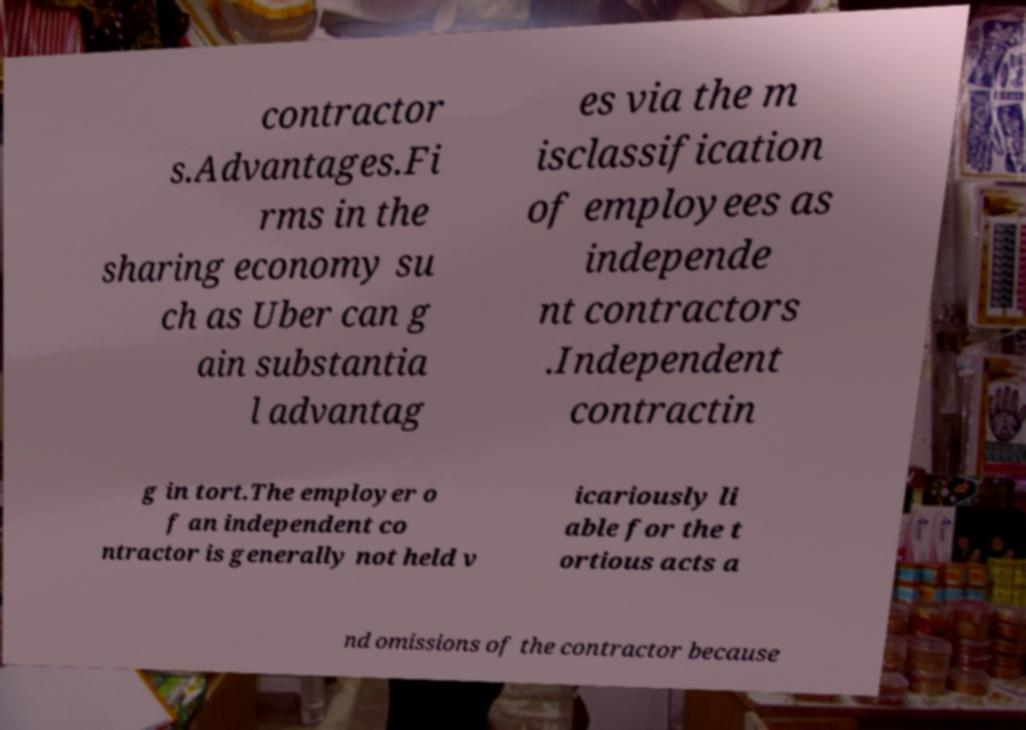Could you assist in decoding the text presented in this image and type it out clearly? contractor s.Advantages.Fi rms in the sharing economy su ch as Uber can g ain substantia l advantag es via the m isclassification of employees as independe nt contractors .Independent contractin g in tort.The employer o f an independent co ntractor is generally not held v icariously li able for the t ortious acts a nd omissions of the contractor because 